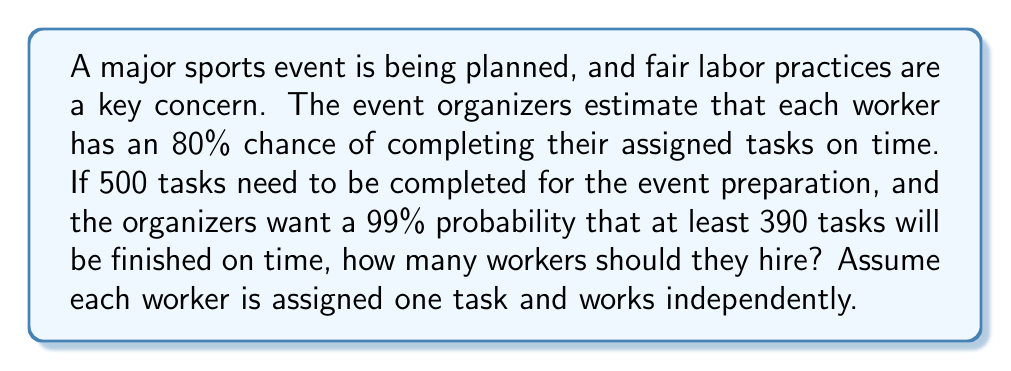What is the answer to this math problem? To solve this problem, we'll use the binomial distribution and its normal approximation.

1) Let $X$ be the number of completed tasks. $X$ follows a binomial distribution with parameters $n$ (number of workers) and $p = 0.8$ (probability of a worker completing their task).

2) We want to find $n$ such that $P(X \geq 390) \geq 0.99$

3) For large $n$, we can approximate the binomial distribution with a normal distribution:

   $X \sim N(np, np(1-p))$

4) We can standardize this to get a z-score:

   $z = \frac{389.5 - np}{\sqrt{np(1-p)}}$

   (We use 389.5 as a continuity correction)

5) We want this z-score to equal -2.326, which corresponds to the 99th percentile of the standard normal distribution:

   $-2.326 = \frac{389.5 - 0.8n}{\sqrt{0.8n(0.2)}}$

6) Squaring both sides and simplifying:

   $5.41 = \frac{(389.5 - 0.8n)^2}{0.16n}$

7) Multiplying both sides by $0.16n$:

   $0.8656n = (389.5 - 0.8n)^2$

8) Expanding the right side:

   $0.8656n = 151700.25 - 622.4n + 0.64n^2$

9) Rearranging:

   $0.64n^2 - 623.2656n + 151700.25 = 0$

10) This is a quadratic equation. Solving it:

    $n = \frac{623.2656 \pm \sqrt{623.2656^2 - 4(0.64)(151700.25)}}{2(0.64)}$

11) Calculating:

    $n \approx 504.8$ or $n \approx 469.1$

12) Since we need an integer number of workers, and we want to ensure we meet or exceed our probability target, we round up to 505.
Answer: The organizers should hire 505 workers to have a 99% probability that at least 390 tasks will be completed on time. 